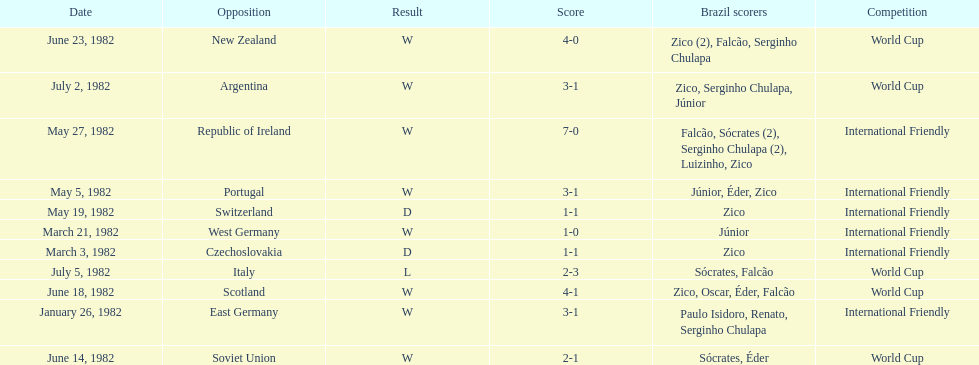What was the total number of losses brazil suffered? 1. 